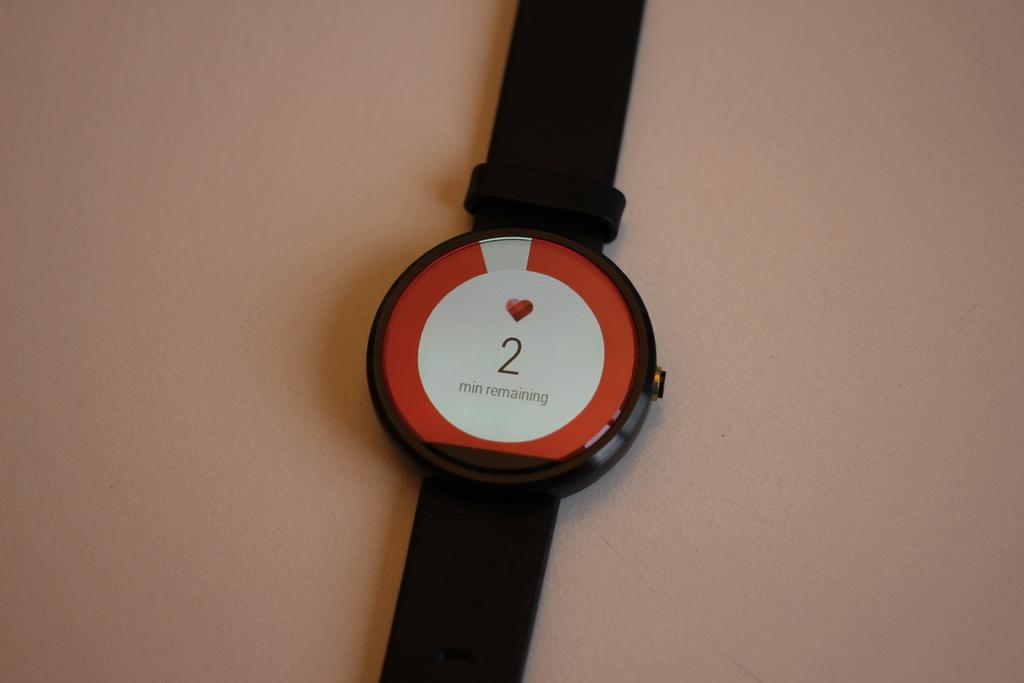<image>
Give a short and clear explanation of the subsequent image. A digital wristwatch with a heart symbol shows "2 min remaining". 